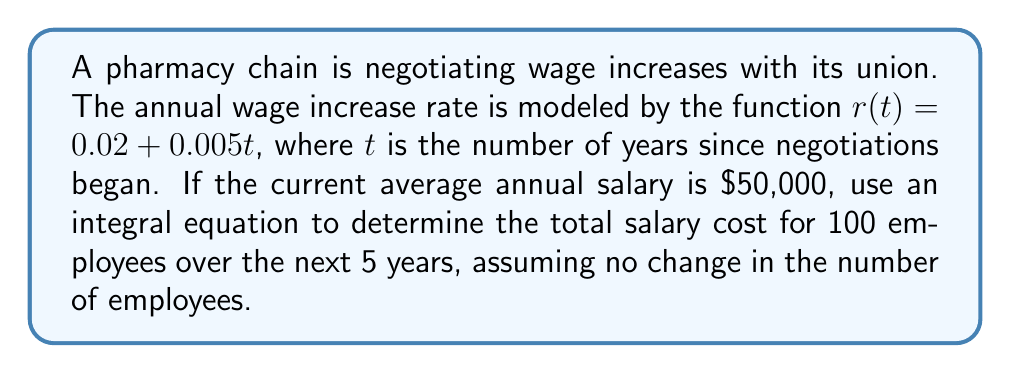What is the answer to this math problem? Let's approach this step-by-step:

1) First, we need to set up an integral equation to model the total salary cost over time. The salary at time $t$ can be expressed as:

   $S(t) = S_0 \cdot e^{\int_0^t r(x) dx}$

   Where $S_0$ is the initial salary and $r(x)$ is the rate function.

2) We're given that $r(t) = 0.02 + 0.005t$ and $S_0 = 50,000$.

3) Let's solve the integral inside the exponential:

   $\int_0^t r(x) dx = \int_0^t (0.02 + 0.005x) dx$
   $= [0.02x + 0.0025x^2]_0^t$
   $= 0.02t + 0.0025t^2$

4) Now our salary function becomes:

   $S(t) = 50,000 \cdot e^{0.02t + 0.0025t^2}$

5) To find the total salary cost over 5 years for 100 employees, we need to integrate this function from 0 to 5 and multiply by 100:

   $\text{Total Cost} = 100 \cdot \int_0^5 50,000 \cdot e^{0.02t + 0.0025t^2} dt$

6) This integral doesn't have a simple analytical solution, so we'll need to use numerical integration methods. Using a computer algebra system or numerical integration tool, we can evaluate this integral:

   $\int_0^5 50,000 \cdot e^{0.02t + 0.0025t^2} dt \approx 263,816.25$

7) Multiplying by 100 employees:

   $\text{Total Cost} = 100 \cdot 263,816.25 = 26,381,625$
Answer: $26,381,625 